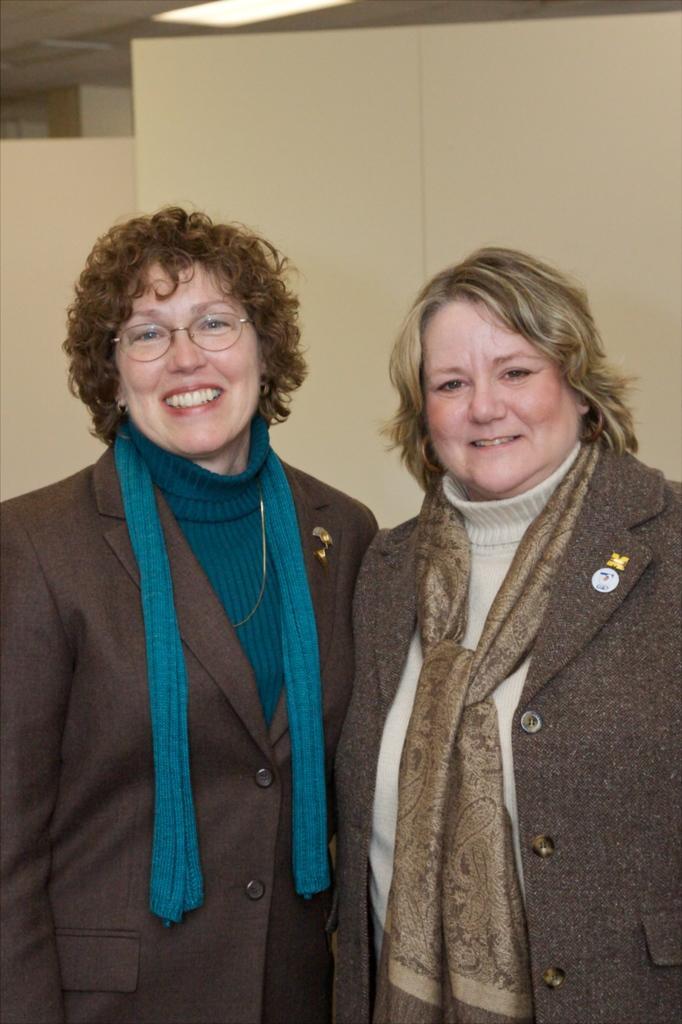Describe this image in one or two sentences. In this picture we can see two women standing and smiling. There is the light and other objects are visible in the background. 